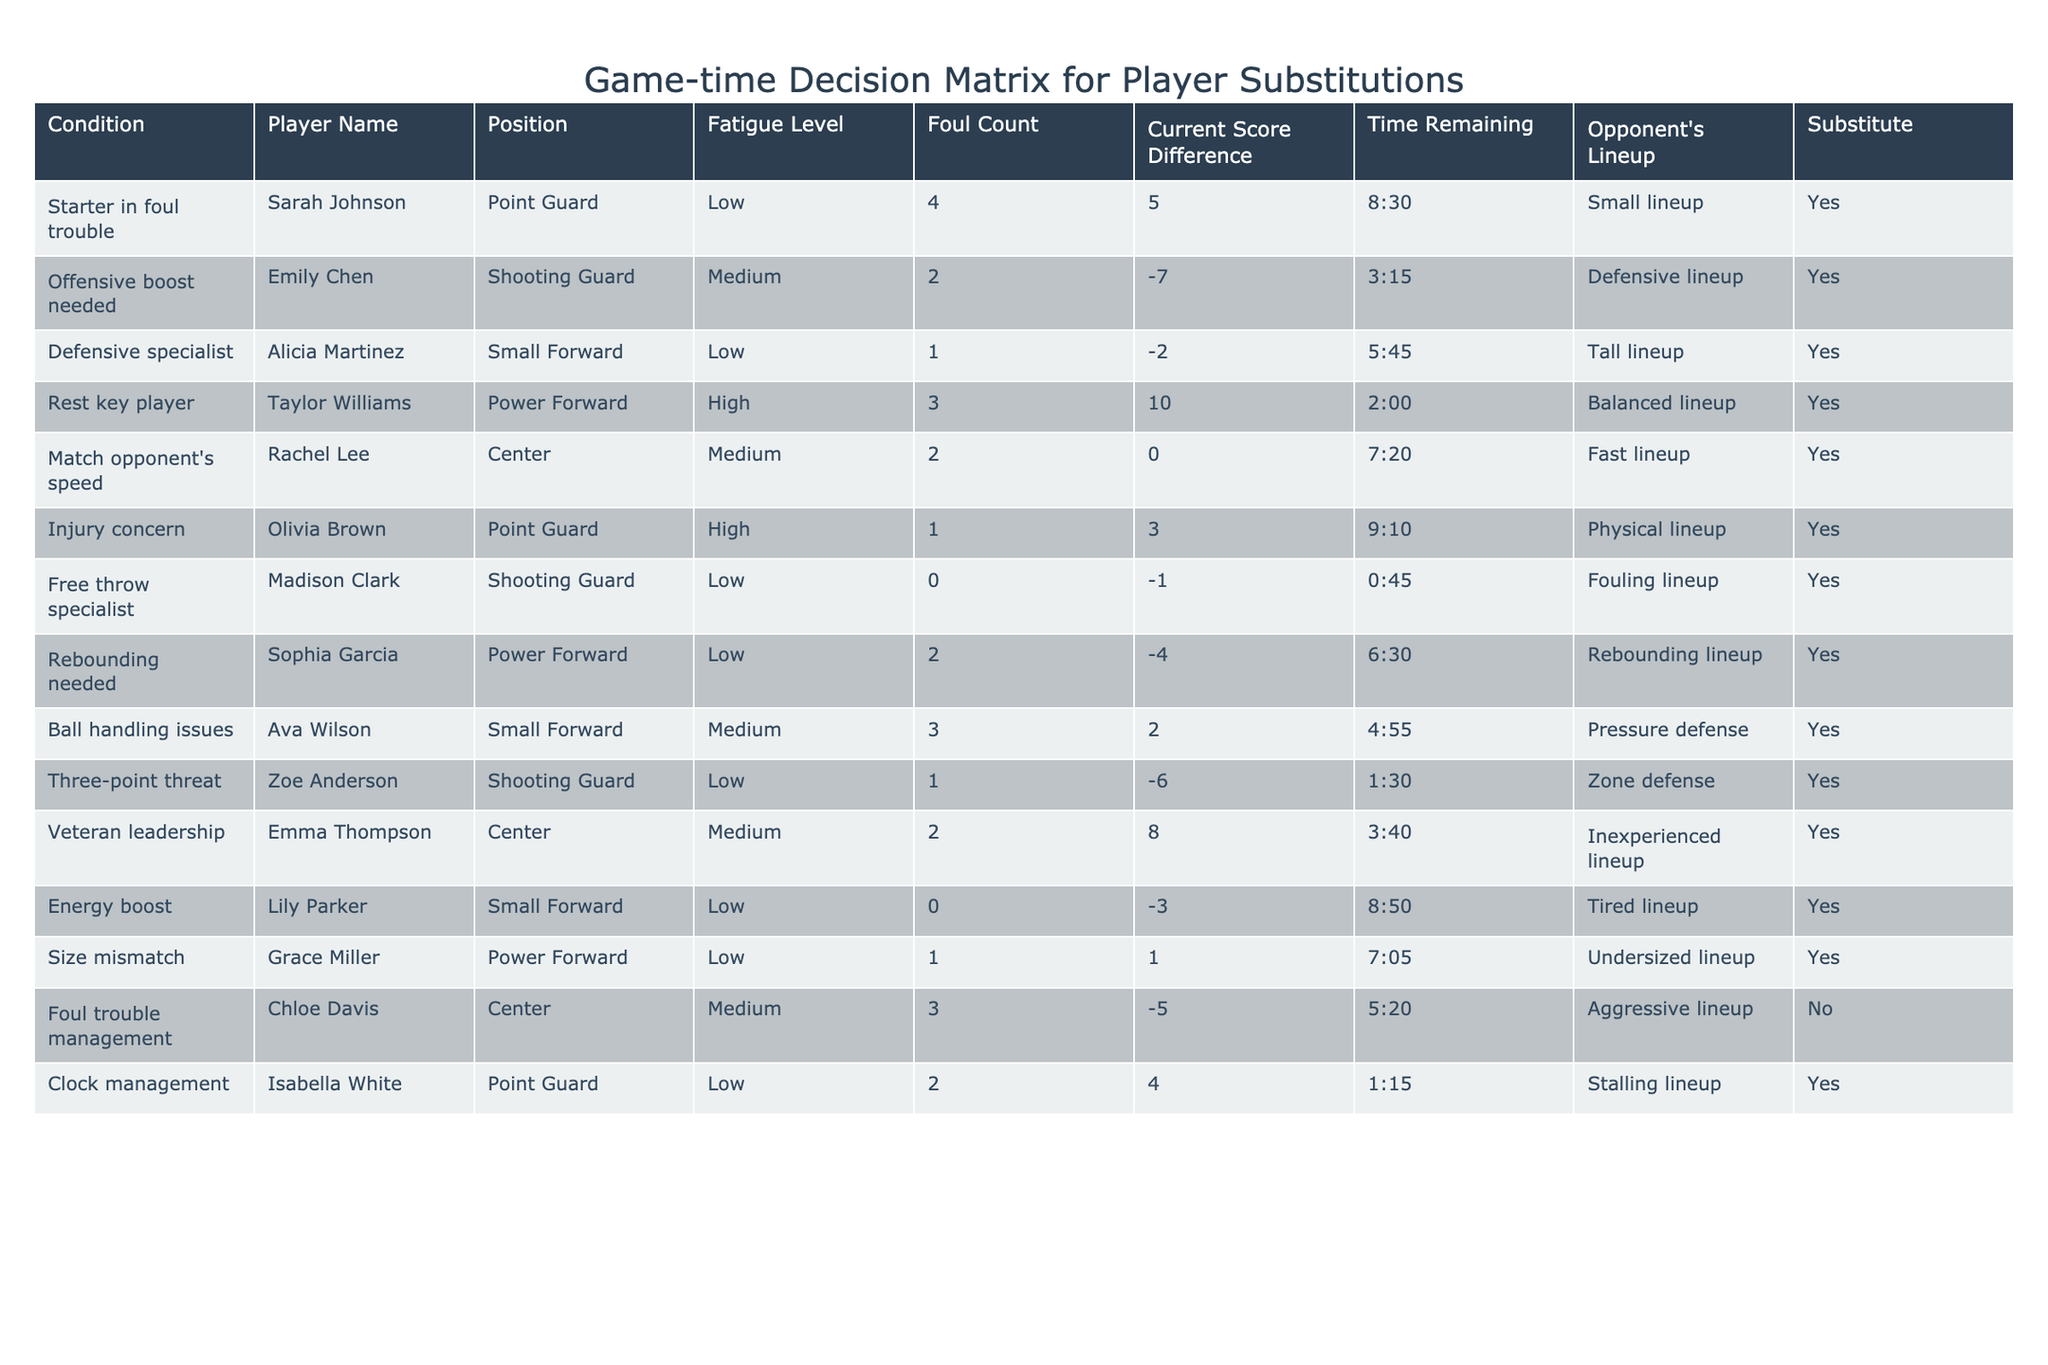What is the fatigue level of Emily Chen? Referring to the table, the row that lists Emily Chen shows that her fatigue level is Medium.
Answer: Medium How many players have a low fatigue level? By counting the players listed in the table with a Low fatigue level, we find that there are 8 players who fit this criterion: Sarah Johnson, Alicia Martinez, Free throw specialist, Zoe Anderson, Lily Parker, Grace Miller, and Sophia Garcia.
Answer: 8 Is Taylor Williams a player who should be substituted? Looking at the row for Taylor Williams, it states that she is in High fatigue level and the condition is "Rest key player," indicating that she should be substituted.
Answer: Yes What is the score difference when Chloe Davis should not be substituted? In the row for Chloe Davis, the score difference is -5, which is when she should not be substituted due to foul trouble management.
Answer: -5 If we consider only the "Defensive boost needed," what is the Current Score Difference? The only player with the condition "Defensive boost needed" is Emily Chen, who has a Current Score Difference of -7.
Answer: -7 How many players have a foul count of 2? From the table, the players with a foul count of 2 are Emily Chen, Rachel Lee, and Isabella White, totaling 3 players.
Answer: 3 What conditions indicate a need for a substitution when the score is in favor of the team? By reviewing the table, Sarah Johnson, Taylor Williams, and Emma Thompson indicate conditions where substitution is considered and the score difference is either +5 or +10 or +8, thus indicating a need for substitution while in favor.
Answer: 3 players Which player has the highest foul count, and what is that count? Looking through the table, the highest foul count is 4 which is assigned to Sarah Johnson, making her the player with the highest foul count.
Answer: 4 Under what conditions is a substitute needed for a player with a high fatigue level? Checking the table reveals two instances where substitutes are needed: Taylor Williams due to High fatigue level to give rest, and Olivia Brown due to Injury concern with High fatigue level, indicating that substitutes are needed under these specific conditions.
Answer: 2 instances 